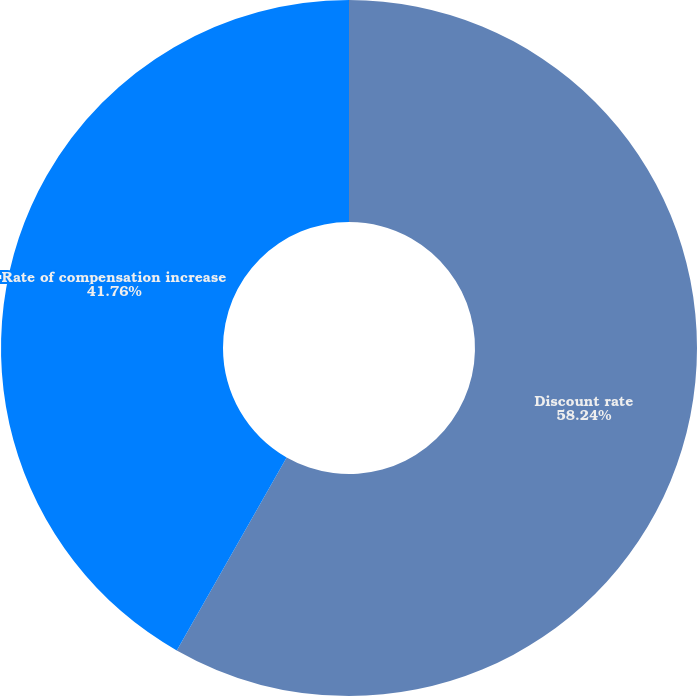<chart> <loc_0><loc_0><loc_500><loc_500><pie_chart><fcel>Discount rate<fcel>Rate of compensation increase<nl><fcel>58.24%<fcel>41.76%<nl></chart> 